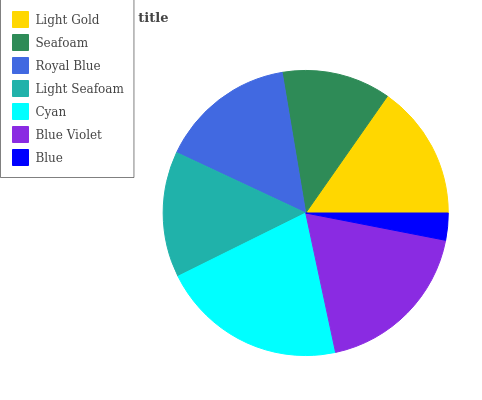Is Blue the minimum?
Answer yes or no. Yes. Is Cyan the maximum?
Answer yes or no. Yes. Is Seafoam the minimum?
Answer yes or no. No. Is Seafoam the maximum?
Answer yes or no. No. Is Light Gold greater than Seafoam?
Answer yes or no. Yes. Is Seafoam less than Light Gold?
Answer yes or no. Yes. Is Seafoam greater than Light Gold?
Answer yes or no. No. Is Light Gold less than Seafoam?
Answer yes or no. No. Is Light Gold the high median?
Answer yes or no. Yes. Is Light Gold the low median?
Answer yes or no. Yes. Is Blue the high median?
Answer yes or no. No. Is Blue Violet the low median?
Answer yes or no. No. 